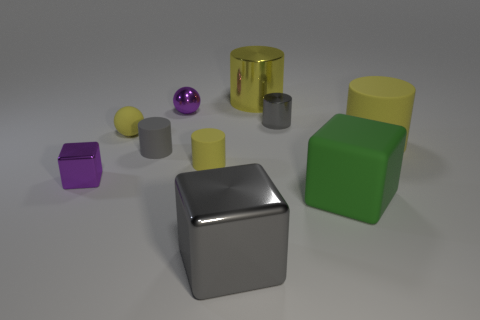What color is the small sphere that is made of the same material as the green cube? The small sphere that shares the same shiny, reflective material quality as the green cube is purple in color. 